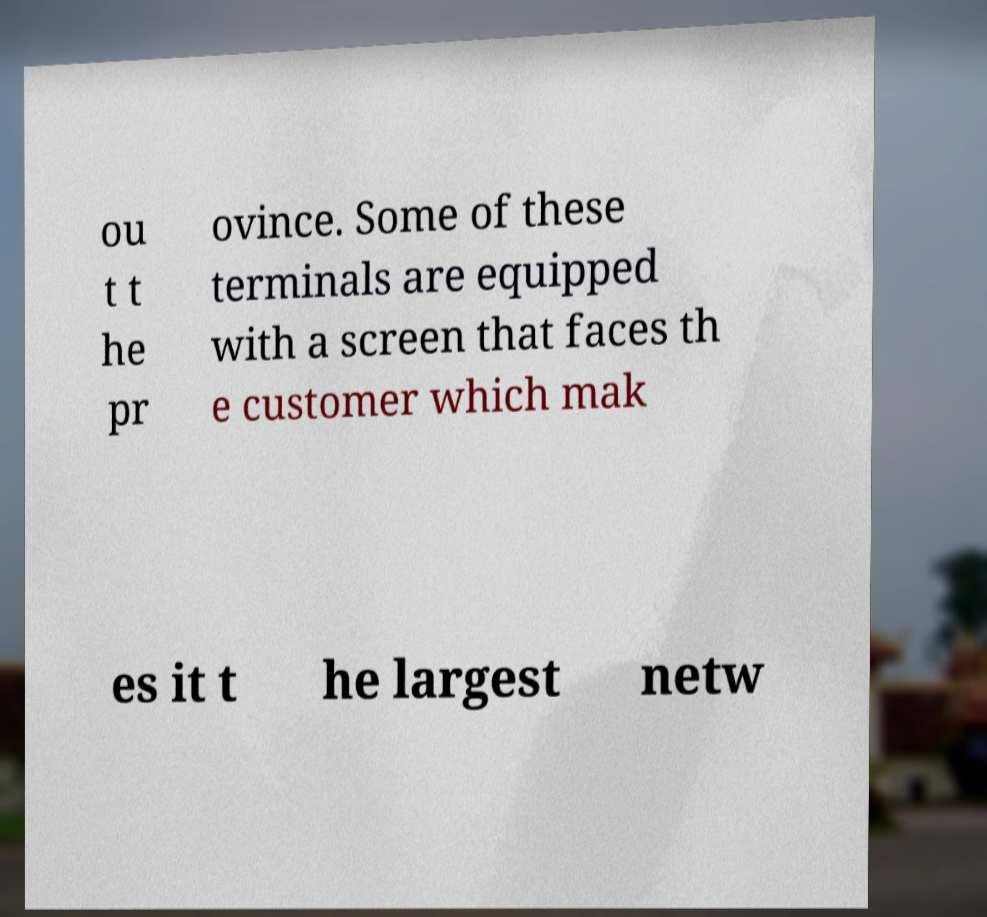There's text embedded in this image that I need extracted. Can you transcribe it verbatim? ou t t he pr ovince. Some of these terminals are equipped with a screen that faces th e customer which mak es it t he largest netw 